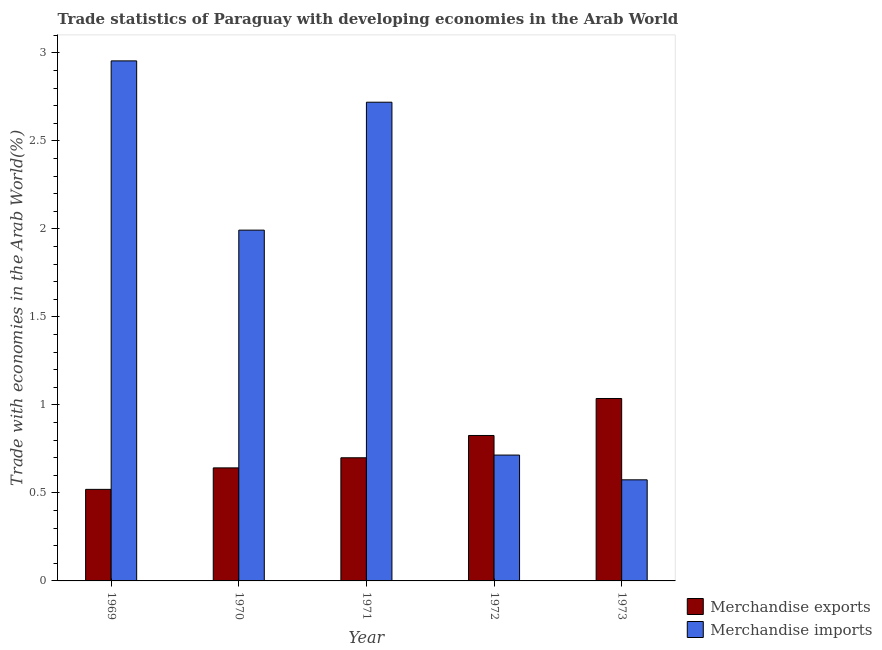How many different coloured bars are there?
Keep it short and to the point. 2. Are the number of bars per tick equal to the number of legend labels?
Provide a succinct answer. Yes. How many bars are there on the 1st tick from the right?
Offer a terse response. 2. In how many cases, is the number of bars for a given year not equal to the number of legend labels?
Ensure brevity in your answer.  0. What is the merchandise exports in 1969?
Make the answer very short. 0.52. Across all years, what is the maximum merchandise exports?
Give a very brief answer. 1.04. Across all years, what is the minimum merchandise imports?
Offer a terse response. 0.57. In which year was the merchandise imports maximum?
Your response must be concise. 1969. In which year was the merchandise imports minimum?
Make the answer very short. 1973. What is the total merchandise imports in the graph?
Your response must be concise. 8.96. What is the difference between the merchandise imports in 1969 and that in 1970?
Give a very brief answer. 0.96. What is the difference between the merchandise imports in 1972 and the merchandise exports in 1973?
Your answer should be compact. 0.14. What is the average merchandise exports per year?
Give a very brief answer. 0.75. In the year 1971, what is the difference between the merchandise exports and merchandise imports?
Make the answer very short. 0. In how many years, is the merchandise exports greater than 2.7 %?
Your answer should be compact. 0. What is the ratio of the merchandise exports in 1969 to that in 1972?
Your answer should be compact. 0.63. Is the merchandise imports in 1971 less than that in 1972?
Provide a succinct answer. No. Is the difference between the merchandise imports in 1970 and 1973 greater than the difference between the merchandise exports in 1970 and 1973?
Your answer should be very brief. No. What is the difference between the highest and the second highest merchandise exports?
Make the answer very short. 0.21. What is the difference between the highest and the lowest merchandise imports?
Give a very brief answer. 2.38. In how many years, is the merchandise exports greater than the average merchandise exports taken over all years?
Offer a very short reply. 2. Is the sum of the merchandise exports in 1971 and 1973 greater than the maximum merchandise imports across all years?
Provide a short and direct response. Yes. What does the 1st bar from the left in 1971 represents?
Offer a terse response. Merchandise exports. How many bars are there?
Give a very brief answer. 10. Are the values on the major ticks of Y-axis written in scientific E-notation?
Ensure brevity in your answer.  No. Where does the legend appear in the graph?
Your response must be concise. Bottom right. How many legend labels are there?
Offer a terse response. 2. What is the title of the graph?
Your answer should be compact. Trade statistics of Paraguay with developing economies in the Arab World. What is the label or title of the Y-axis?
Give a very brief answer. Trade with economies in the Arab World(%). What is the Trade with economies in the Arab World(%) in Merchandise exports in 1969?
Make the answer very short. 0.52. What is the Trade with economies in the Arab World(%) of Merchandise imports in 1969?
Your answer should be very brief. 2.95. What is the Trade with economies in the Arab World(%) of Merchandise exports in 1970?
Make the answer very short. 0.64. What is the Trade with economies in the Arab World(%) in Merchandise imports in 1970?
Keep it short and to the point. 1.99. What is the Trade with economies in the Arab World(%) in Merchandise exports in 1971?
Ensure brevity in your answer.  0.7. What is the Trade with economies in the Arab World(%) in Merchandise imports in 1971?
Your response must be concise. 2.72. What is the Trade with economies in the Arab World(%) in Merchandise exports in 1972?
Offer a terse response. 0.83. What is the Trade with economies in the Arab World(%) in Merchandise imports in 1972?
Your answer should be very brief. 0.72. What is the Trade with economies in the Arab World(%) in Merchandise exports in 1973?
Provide a short and direct response. 1.04. What is the Trade with economies in the Arab World(%) in Merchandise imports in 1973?
Your answer should be compact. 0.57. Across all years, what is the maximum Trade with economies in the Arab World(%) of Merchandise exports?
Offer a terse response. 1.04. Across all years, what is the maximum Trade with economies in the Arab World(%) of Merchandise imports?
Your response must be concise. 2.95. Across all years, what is the minimum Trade with economies in the Arab World(%) of Merchandise exports?
Provide a succinct answer. 0.52. Across all years, what is the minimum Trade with economies in the Arab World(%) in Merchandise imports?
Provide a short and direct response. 0.57. What is the total Trade with economies in the Arab World(%) in Merchandise exports in the graph?
Your answer should be compact. 3.73. What is the total Trade with economies in the Arab World(%) of Merchandise imports in the graph?
Give a very brief answer. 8.96. What is the difference between the Trade with economies in the Arab World(%) in Merchandise exports in 1969 and that in 1970?
Your response must be concise. -0.12. What is the difference between the Trade with economies in the Arab World(%) in Merchandise imports in 1969 and that in 1970?
Offer a terse response. 0.96. What is the difference between the Trade with economies in the Arab World(%) of Merchandise exports in 1969 and that in 1971?
Your answer should be very brief. -0.18. What is the difference between the Trade with economies in the Arab World(%) of Merchandise imports in 1969 and that in 1971?
Provide a succinct answer. 0.23. What is the difference between the Trade with economies in the Arab World(%) in Merchandise exports in 1969 and that in 1972?
Offer a very short reply. -0.31. What is the difference between the Trade with economies in the Arab World(%) of Merchandise imports in 1969 and that in 1972?
Make the answer very short. 2.24. What is the difference between the Trade with economies in the Arab World(%) of Merchandise exports in 1969 and that in 1973?
Give a very brief answer. -0.52. What is the difference between the Trade with economies in the Arab World(%) in Merchandise imports in 1969 and that in 1973?
Keep it short and to the point. 2.38. What is the difference between the Trade with economies in the Arab World(%) in Merchandise exports in 1970 and that in 1971?
Give a very brief answer. -0.06. What is the difference between the Trade with economies in the Arab World(%) in Merchandise imports in 1970 and that in 1971?
Your response must be concise. -0.73. What is the difference between the Trade with economies in the Arab World(%) of Merchandise exports in 1970 and that in 1972?
Keep it short and to the point. -0.18. What is the difference between the Trade with economies in the Arab World(%) in Merchandise imports in 1970 and that in 1972?
Provide a short and direct response. 1.28. What is the difference between the Trade with economies in the Arab World(%) in Merchandise exports in 1970 and that in 1973?
Keep it short and to the point. -0.39. What is the difference between the Trade with economies in the Arab World(%) of Merchandise imports in 1970 and that in 1973?
Your answer should be very brief. 1.42. What is the difference between the Trade with economies in the Arab World(%) in Merchandise exports in 1971 and that in 1972?
Your response must be concise. -0.13. What is the difference between the Trade with economies in the Arab World(%) of Merchandise imports in 1971 and that in 1972?
Offer a very short reply. 2. What is the difference between the Trade with economies in the Arab World(%) in Merchandise exports in 1971 and that in 1973?
Your answer should be very brief. -0.34. What is the difference between the Trade with economies in the Arab World(%) in Merchandise imports in 1971 and that in 1973?
Give a very brief answer. 2.15. What is the difference between the Trade with economies in the Arab World(%) of Merchandise exports in 1972 and that in 1973?
Give a very brief answer. -0.21. What is the difference between the Trade with economies in the Arab World(%) in Merchandise imports in 1972 and that in 1973?
Keep it short and to the point. 0.14. What is the difference between the Trade with economies in the Arab World(%) of Merchandise exports in 1969 and the Trade with economies in the Arab World(%) of Merchandise imports in 1970?
Make the answer very short. -1.47. What is the difference between the Trade with economies in the Arab World(%) in Merchandise exports in 1969 and the Trade with economies in the Arab World(%) in Merchandise imports in 1971?
Provide a short and direct response. -2.2. What is the difference between the Trade with economies in the Arab World(%) of Merchandise exports in 1969 and the Trade with economies in the Arab World(%) of Merchandise imports in 1972?
Keep it short and to the point. -0.19. What is the difference between the Trade with economies in the Arab World(%) of Merchandise exports in 1969 and the Trade with economies in the Arab World(%) of Merchandise imports in 1973?
Ensure brevity in your answer.  -0.05. What is the difference between the Trade with economies in the Arab World(%) of Merchandise exports in 1970 and the Trade with economies in the Arab World(%) of Merchandise imports in 1971?
Provide a short and direct response. -2.08. What is the difference between the Trade with economies in the Arab World(%) of Merchandise exports in 1970 and the Trade with economies in the Arab World(%) of Merchandise imports in 1972?
Your response must be concise. -0.07. What is the difference between the Trade with economies in the Arab World(%) of Merchandise exports in 1970 and the Trade with economies in the Arab World(%) of Merchandise imports in 1973?
Ensure brevity in your answer.  0.07. What is the difference between the Trade with economies in the Arab World(%) of Merchandise exports in 1971 and the Trade with economies in the Arab World(%) of Merchandise imports in 1972?
Offer a very short reply. -0.02. What is the difference between the Trade with economies in the Arab World(%) of Merchandise exports in 1971 and the Trade with economies in the Arab World(%) of Merchandise imports in 1973?
Provide a succinct answer. 0.13. What is the difference between the Trade with economies in the Arab World(%) in Merchandise exports in 1972 and the Trade with economies in the Arab World(%) in Merchandise imports in 1973?
Offer a very short reply. 0.25. What is the average Trade with economies in the Arab World(%) in Merchandise exports per year?
Your response must be concise. 0.74. What is the average Trade with economies in the Arab World(%) in Merchandise imports per year?
Make the answer very short. 1.79. In the year 1969, what is the difference between the Trade with economies in the Arab World(%) of Merchandise exports and Trade with economies in the Arab World(%) of Merchandise imports?
Provide a short and direct response. -2.43. In the year 1970, what is the difference between the Trade with economies in the Arab World(%) of Merchandise exports and Trade with economies in the Arab World(%) of Merchandise imports?
Your answer should be very brief. -1.35. In the year 1971, what is the difference between the Trade with economies in the Arab World(%) of Merchandise exports and Trade with economies in the Arab World(%) of Merchandise imports?
Your answer should be compact. -2.02. In the year 1972, what is the difference between the Trade with economies in the Arab World(%) in Merchandise exports and Trade with economies in the Arab World(%) in Merchandise imports?
Your answer should be compact. 0.11. In the year 1973, what is the difference between the Trade with economies in the Arab World(%) of Merchandise exports and Trade with economies in the Arab World(%) of Merchandise imports?
Provide a short and direct response. 0.46. What is the ratio of the Trade with economies in the Arab World(%) of Merchandise exports in 1969 to that in 1970?
Offer a terse response. 0.81. What is the ratio of the Trade with economies in the Arab World(%) in Merchandise imports in 1969 to that in 1970?
Your answer should be very brief. 1.48. What is the ratio of the Trade with economies in the Arab World(%) of Merchandise exports in 1969 to that in 1971?
Keep it short and to the point. 0.74. What is the ratio of the Trade with economies in the Arab World(%) in Merchandise imports in 1969 to that in 1971?
Provide a short and direct response. 1.09. What is the ratio of the Trade with economies in the Arab World(%) of Merchandise exports in 1969 to that in 1972?
Your response must be concise. 0.63. What is the ratio of the Trade with economies in the Arab World(%) in Merchandise imports in 1969 to that in 1972?
Make the answer very short. 4.13. What is the ratio of the Trade with economies in the Arab World(%) in Merchandise exports in 1969 to that in 1973?
Give a very brief answer. 0.5. What is the ratio of the Trade with economies in the Arab World(%) in Merchandise imports in 1969 to that in 1973?
Keep it short and to the point. 5.14. What is the ratio of the Trade with economies in the Arab World(%) of Merchandise exports in 1970 to that in 1971?
Provide a short and direct response. 0.92. What is the ratio of the Trade with economies in the Arab World(%) in Merchandise imports in 1970 to that in 1971?
Your response must be concise. 0.73. What is the ratio of the Trade with economies in the Arab World(%) in Merchandise exports in 1970 to that in 1972?
Make the answer very short. 0.78. What is the ratio of the Trade with economies in the Arab World(%) in Merchandise imports in 1970 to that in 1972?
Keep it short and to the point. 2.79. What is the ratio of the Trade with economies in the Arab World(%) of Merchandise exports in 1970 to that in 1973?
Offer a terse response. 0.62. What is the ratio of the Trade with economies in the Arab World(%) of Merchandise imports in 1970 to that in 1973?
Offer a terse response. 3.47. What is the ratio of the Trade with economies in the Arab World(%) in Merchandise exports in 1971 to that in 1972?
Your response must be concise. 0.85. What is the ratio of the Trade with economies in the Arab World(%) in Merchandise imports in 1971 to that in 1972?
Your answer should be very brief. 3.8. What is the ratio of the Trade with economies in the Arab World(%) in Merchandise exports in 1971 to that in 1973?
Ensure brevity in your answer.  0.68. What is the ratio of the Trade with economies in the Arab World(%) of Merchandise imports in 1971 to that in 1973?
Give a very brief answer. 4.74. What is the ratio of the Trade with economies in the Arab World(%) of Merchandise exports in 1972 to that in 1973?
Offer a terse response. 0.8. What is the ratio of the Trade with economies in the Arab World(%) in Merchandise imports in 1972 to that in 1973?
Keep it short and to the point. 1.24. What is the difference between the highest and the second highest Trade with economies in the Arab World(%) of Merchandise exports?
Your answer should be very brief. 0.21. What is the difference between the highest and the second highest Trade with economies in the Arab World(%) of Merchandise imports?
Your answer should be compact. 0.23. What is the difference between the highest and the lowest Trade with economies in the Arab World(%) of Merchandise exports?
Give a very brief answer. 0.52. What is the difference between the highest and the lowest Trade with economies in the Arab World(%) in Merchandise imports?
Your answer should be very brief. 2.38. 